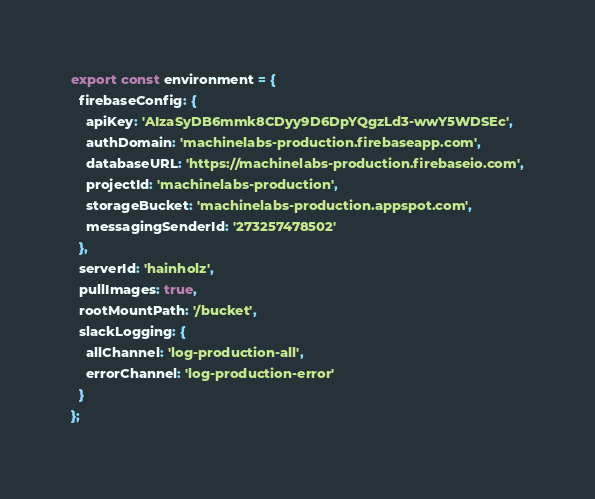Convert code to text. <code><loc_0><loc_0><loc_500><loc_500><_TypeScript_>export const environment = {
  firebaseConfig: {
    apiKey: 'AIzaSyDB6mmk8CDyy9D6DpYQgzLd3-wwY5WDSEc',
    authDomain: 'machinelabs-production.firebaseapp.com',
    databaseURL: 'https://machinelabs-production.firebaseio.com',
    projectId: 'machinelabs-production',
    storageBucket: 'machinelabs-production.appspot.com',
    messagingSenderId: '273257478502'
  },
  serverId: 'hainholz',
  pullImages: true,
  rootMountPath: '/bucket',
  slackLogging: {
    allChannel: 'log-production-all',
    errorChannel: 'log-production-error'
  }
};
</code> 